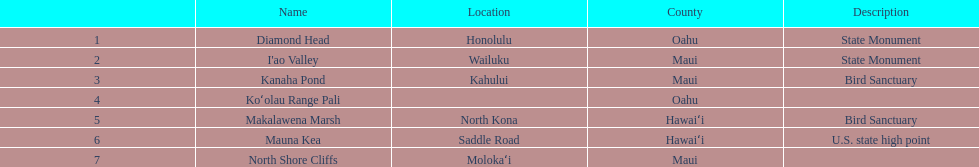Which national natural landmarks in hawaii are in oahu county? Diamond Head, Koʻolau Range Pali. Of these landmarks, which one is listed without a location? Koʻolau Range Pali. 